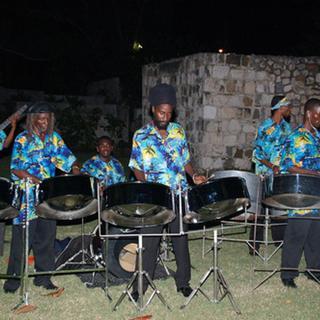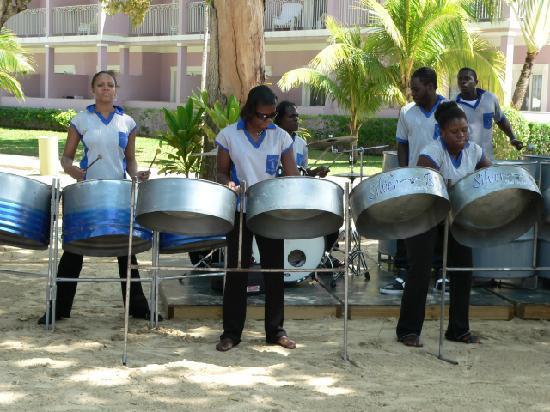The first image is the image on the left, the second image is the image on the right. Considering the images on both sides, is "In one of the images, three people in straw hats are playing instruments." valid? Answer yes or no. No. The first image is the image on the left, the second image is the image on the right. Assess this claim about the two images: "Exactly one of the bands is playing in sand.". Correct or not? Answer yes or no. Yes. 